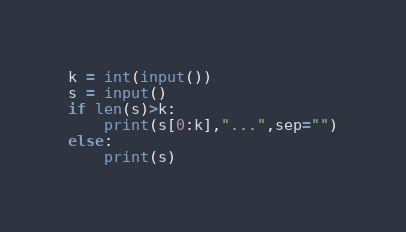<code> <loc_0><loc_0><loc_500><loc_500><_Python_>k = int(input())
s = input()
if len(s)>k:
    print(s[0:k],"...",sep="")
else:
    print(s)</code> 